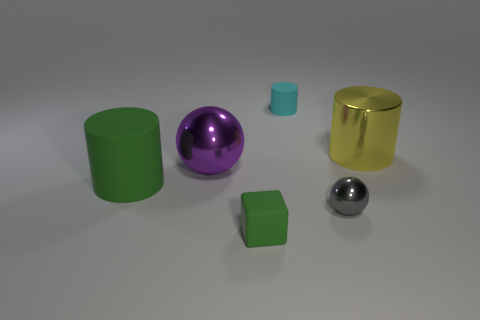Subtract 1 cylinders. How many cylinders are left? 2 Add 2 small gray things. How many objects exist? 8 Subtract all blocks. How many objects are left? 5 Add 4 matte things. How many matte things exist? 7 Subtract 0 cyan cubes. How many objects are left? 6 Subtract all yellow metallic objects. Subtract all large purple metal balls. How many objects are left? 4 Add 1 large green cylinders. How many large green cylinders are left? 2 